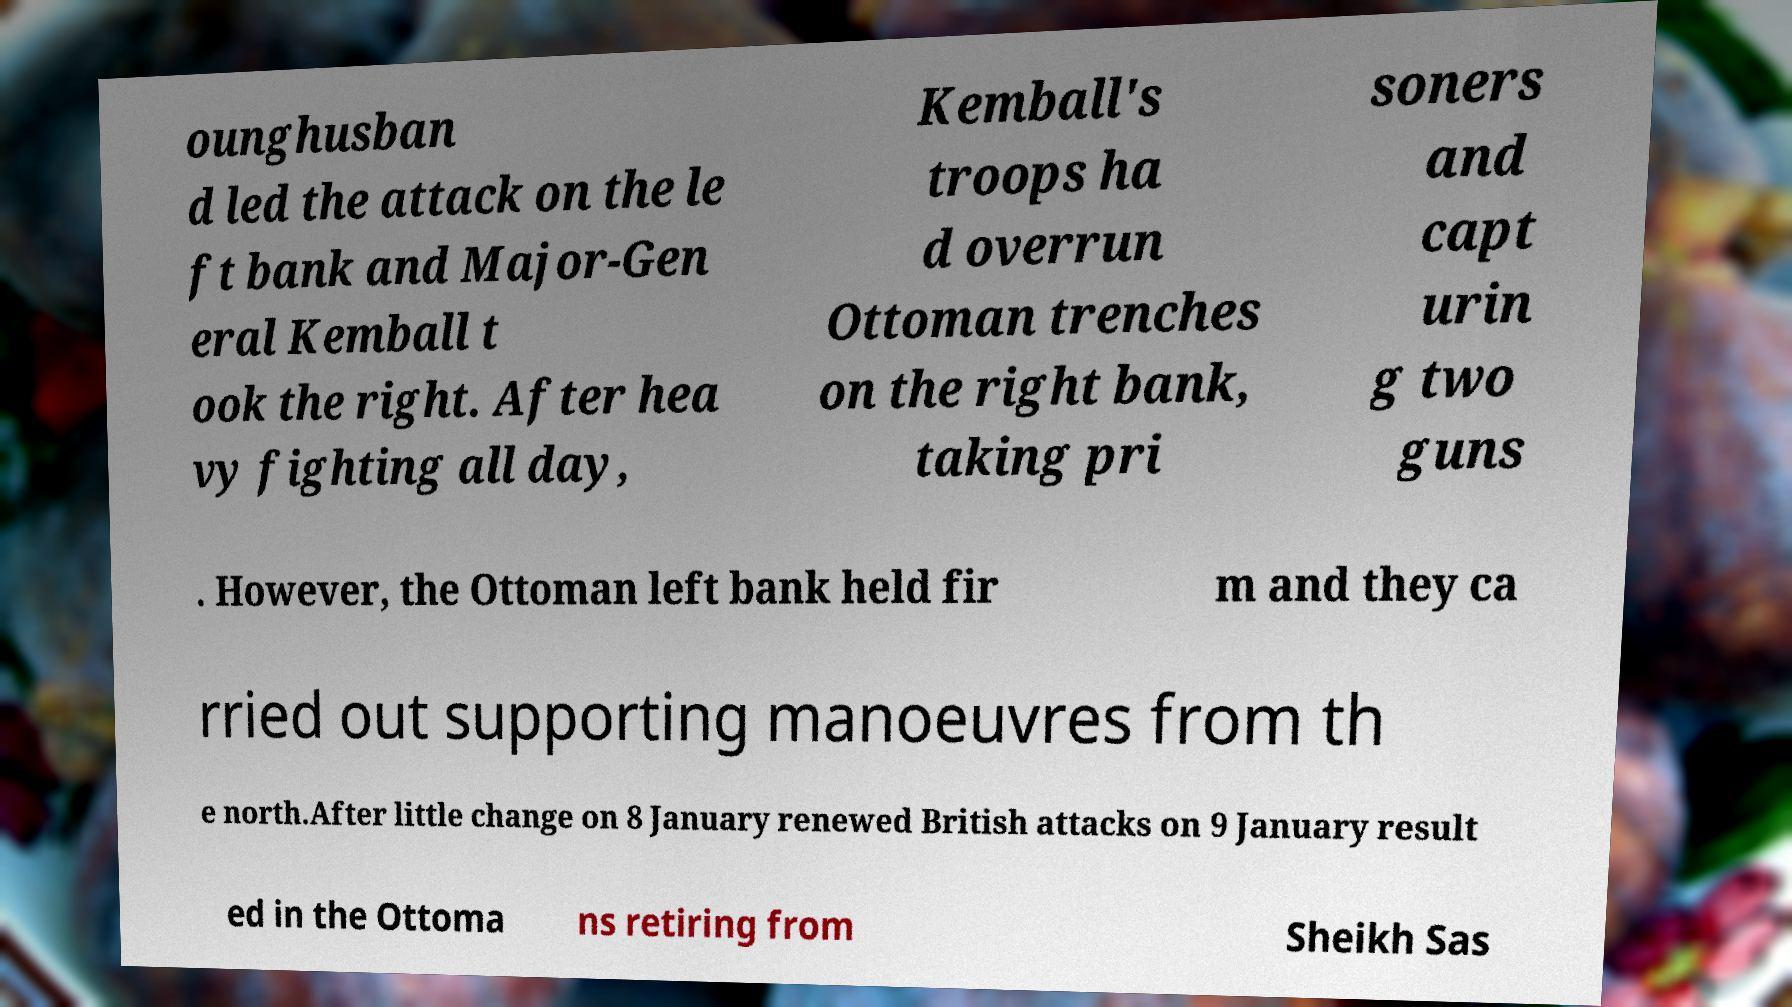For documentation purposes, I need the text within this image transcribed. Could you provide that? ounghusban d led the attack on the le ft bank and Major-Gen eral Kemball t ook the right. After hea vy fighting all day, Kemball's troops ha d overrun Ottoman trenches on the right bank, taking pri soners and capt urin g two guns . However, the Ottoman left bank held fir m and they ca rried out supporting manoeuvres from th e north.After little change on 8 January renewed British attacks on 9 January result ed in the Ottoma ns retiring from Sheikh Sas 